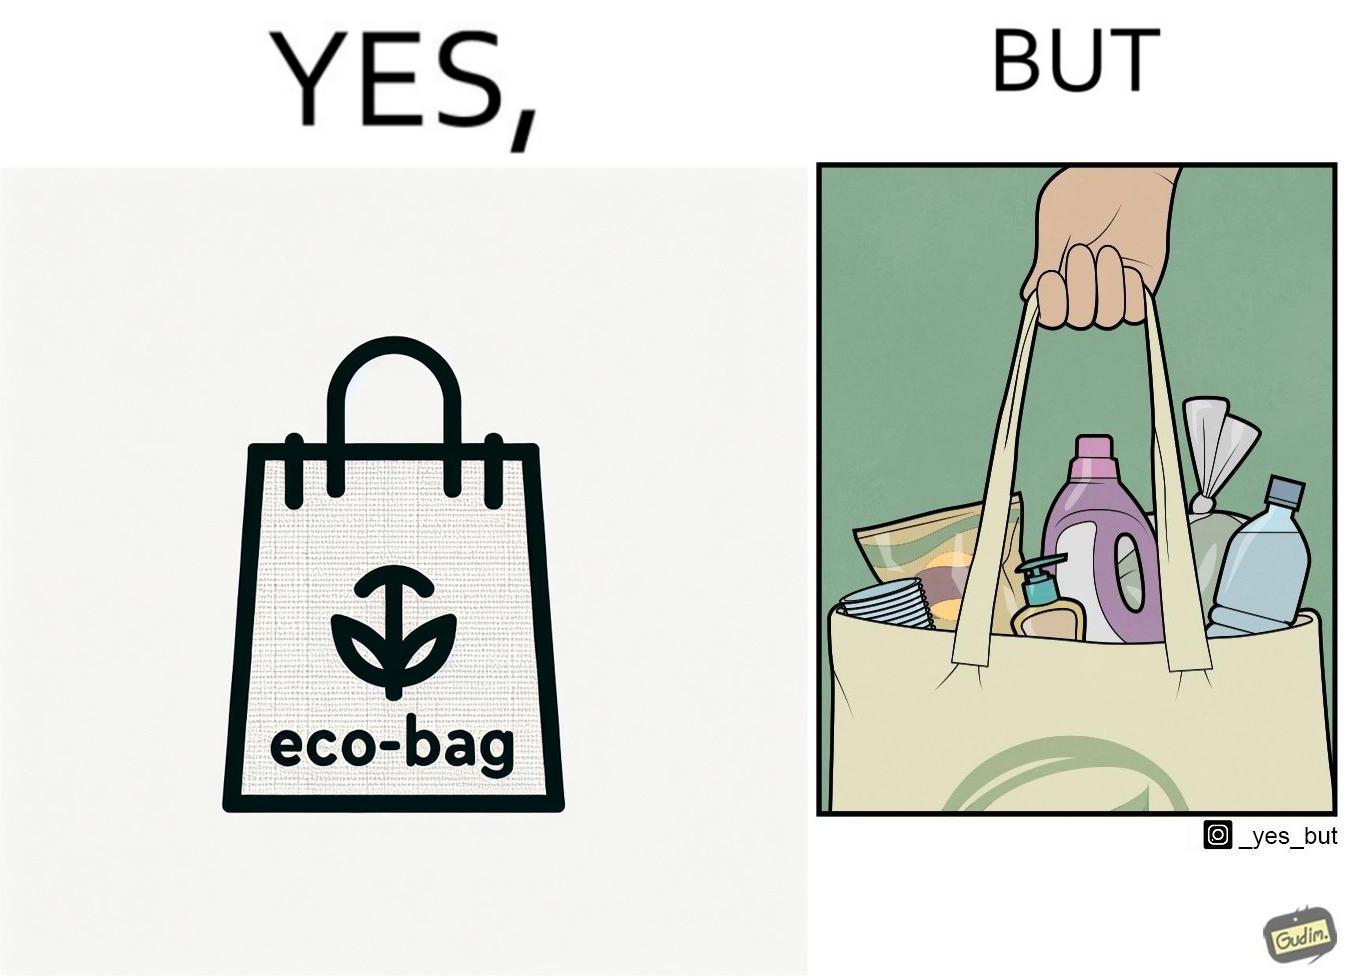Describe the content of this image. The image is ironic, because people nowadays use eco-bag thinking them as safe for the environment but in turn use products which are harmful for the environment or are packaged in some non-biodegradable material 